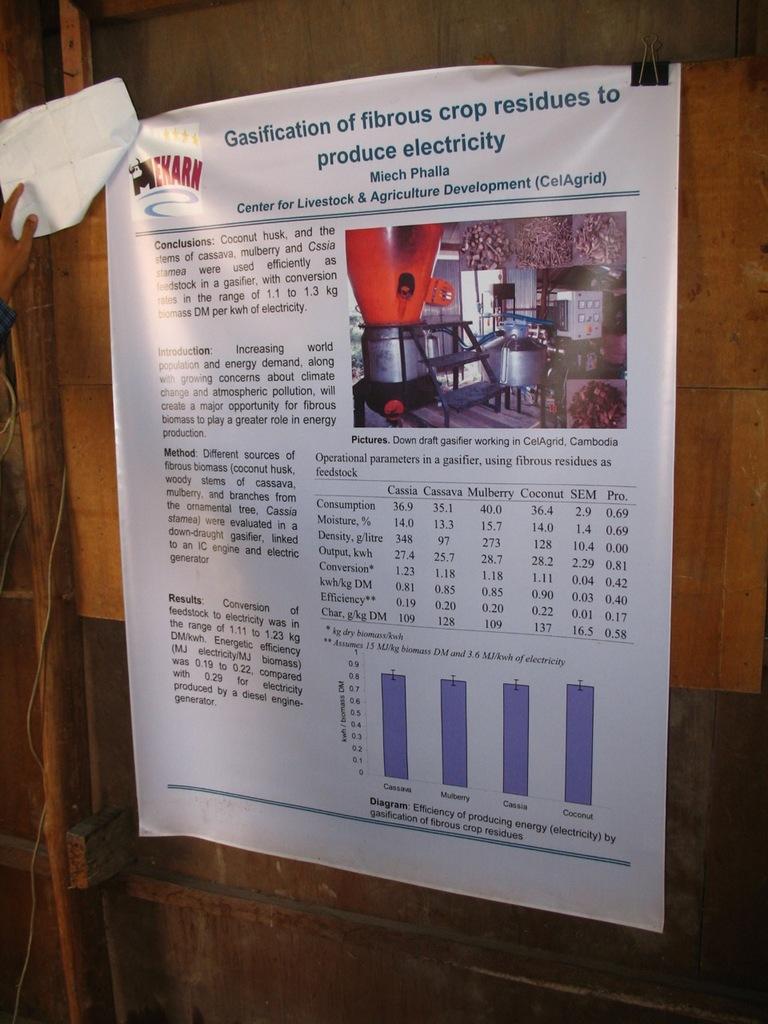Was this by the center of livestock?
Ensure brevity in your answer.  Yes. What does crop residue produce?
Provide a short and direct response. Electricity. 